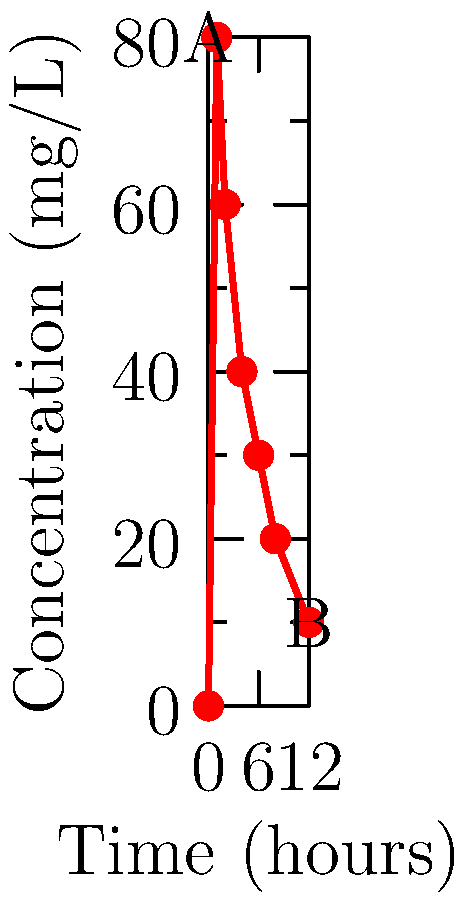In a pharmacokinetic study, the concentration of a new drug was measured in a patient's bloodstream over time. The graph shows the drug concentration (mg/L) on the y-axis and time (hours) on the x-axis. What is the drug's half-life, assuming first-order elimination kinetics? To determine the drug's half-life, we need to follow these steps:

1. Identify two points on the curve for calculation. Let's use points A (0h, 80mg/L) and B (12h, 10mg/L).

2. Calculate the elimination rate constant (k) using the first-order elimination equation:
   $$C_t = C_0 e^{-kt}$$
   where $C_t$ is the concentration at time t, $C_0$ is the initial concentration, k is the elimination rate constant, and t is time.

3. Rearrange the equation to solve for k:
   $$k = -\frac{\ln(C_t/C_0)}{t}$$

4. Plug in the values:
   $$k = -\frac{\ln(10/80)}{12} = 0.1733 \text{ h}^{-1}$$

5. Calculate the half-life using the formula:
   $$t_{1/2} = \frac{\ln(2)}{k}$$

6. Plug in the value of k:
   $$t_{1/2} = \frac{\ln(2)}{0.1733} = 4 \text{ hours}$$

Therefore, the drug's half-life is approximately 4 hours.
Answer: 4 hours 